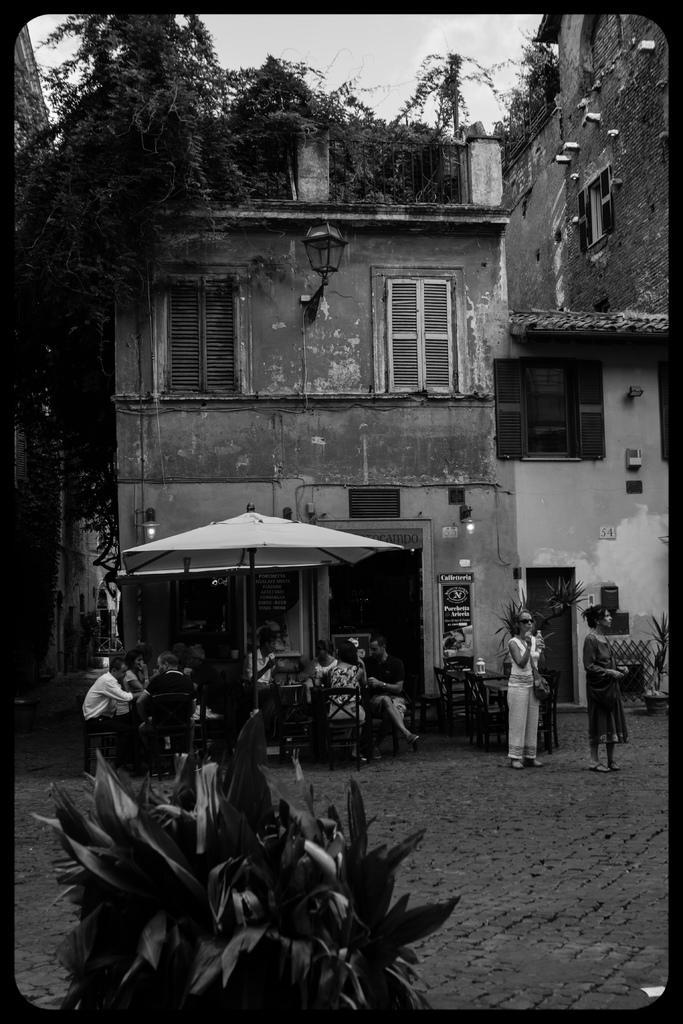Please provide a concise description of this image. In this image, we can see some persons wearing clothes and sitting on chairs. There is an umbrella in front of the building. There is a tree and sky at the top of the image. There are two persons on the right side of the image standing and wearing clothes. There is a plant at the bottom of the image. 